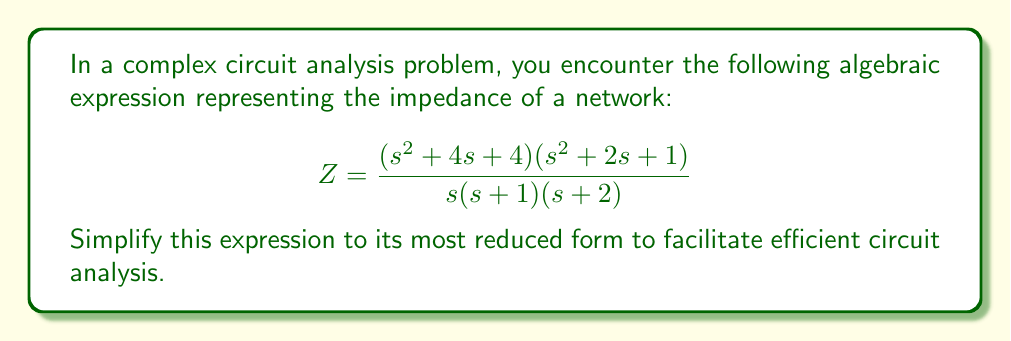Provide a solution to this math problem. Let's simplify this expression step-by-step:

1) First, let's factor the numerator:
   $$(s^2 + 4s + 4)(s^2 + 2s + 1) = (s + 2)^2(s + 1)^2$$

2) Now our expression looks like:
   $$Z = \frac{(s + 2)^2(s + 1)^2}{s(s + 1)(s + 2)}$$

3) We can cancel out common factors in the numerator and denominator:
   - $(s + 1)$ cancels once
   - $(s + 2)$ cancels once

4) After cancellation, we're left with:
   $$Z = \frac{(s + 2)(s + 1)}{s}$$

5) This is the most reduced form of the expression. We can't simplify it further because there are no more common factors between the numerator and denominator.
Answer: $$Z = \frac{(s + 2)(s + 1)}{s}$$ 